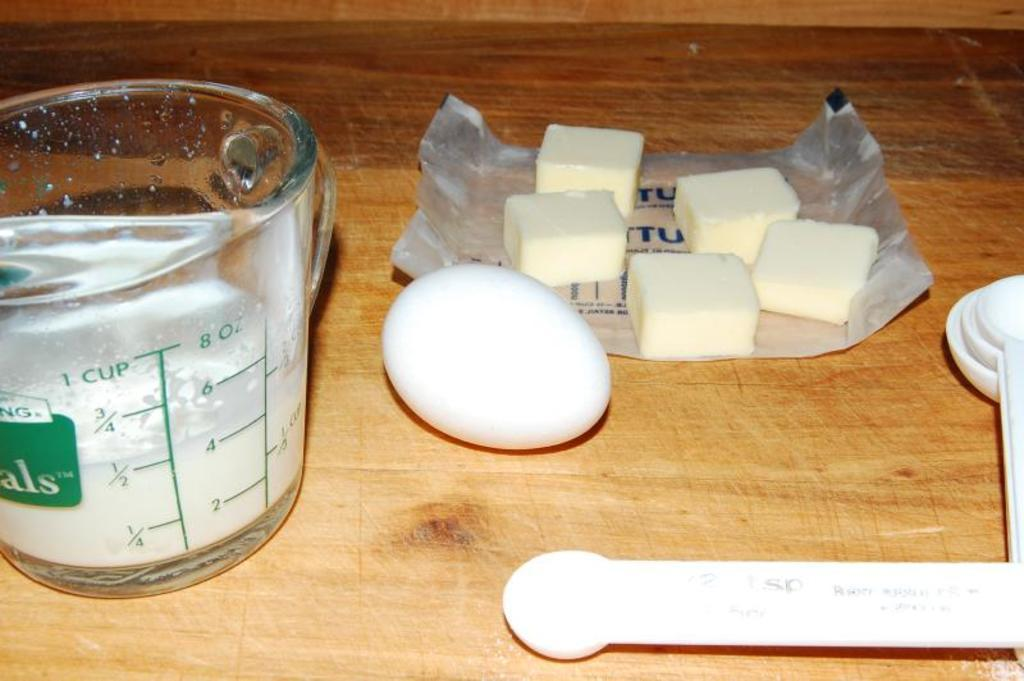<image>
Share a concise interpretation of the image provided. Half of a cup of flour sits in a measuring cup on a countertop. 